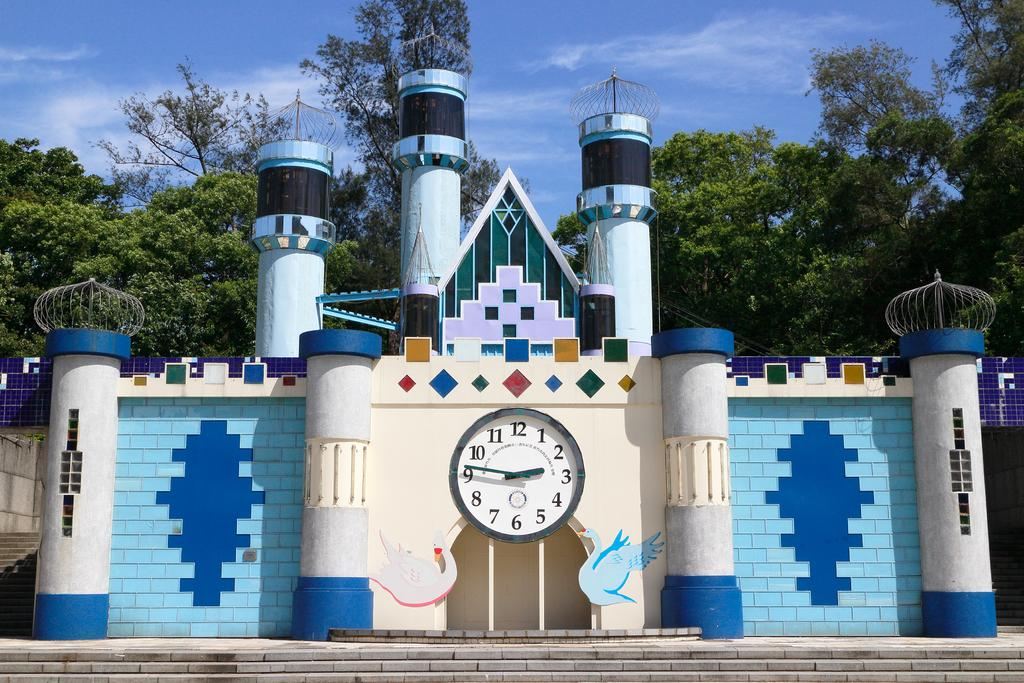<image>
Write a terse but informative summary of the picture. A clock on a castle has the time of 2:46. 